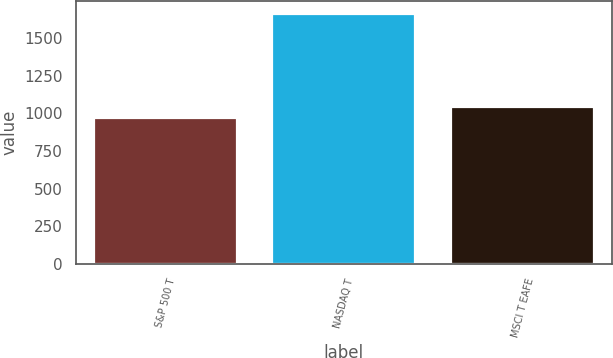Convert chart to OTSL. <chart><loc_0><loc_0><loc_500><loc_500><bar_chart><fcel>S&P 500 T<fcel>NASDAQ T<fcel>MSCI T EAFE<nl><fcel>967.9<fcel>1659.2<fcel>1044.3<nl></chart> 